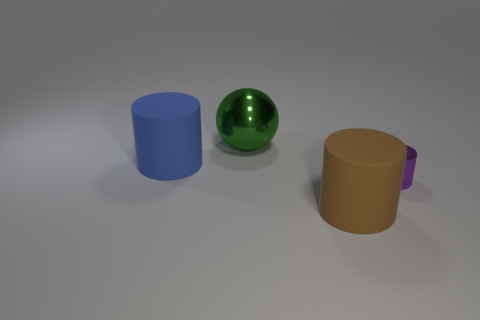Add 3 big cylinders. How many objects exist? 7 Subtract all balls. How many objects are left? 3 Add 3 purple shiny objects. How many purple shiny objects are left? 4 Add 4 green metallic balls. How many green metallic balls exist? 5 Subtract 1 green balls. How many objects are left? 3 Subtract all cylinders. Subtract all brown matte cylinders. How many objects are left? 0 